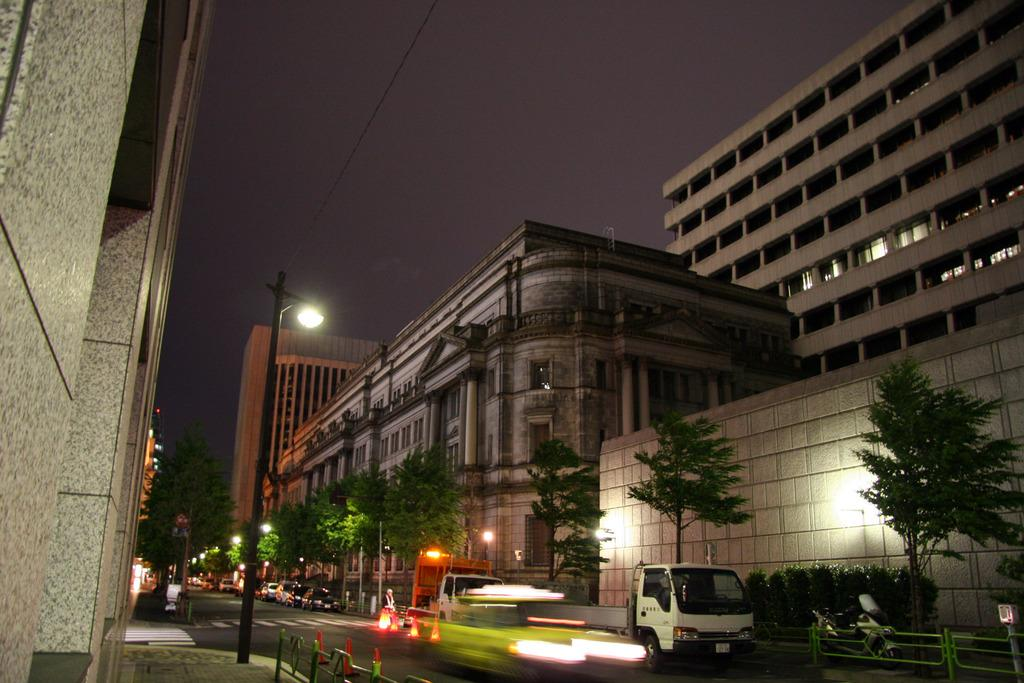What is happening on the road in the image? There are vehicles on the road in the image. What might be used to direct traffic or indicate a hazard in the image? Traffic cones are present on the road in the image. What can be seen in the background of the image? There are trees, poles, buildings, and lights in the background of the image. What type of pump can be seen in the image? There is no pump present in the image. What trick is being performed by the vehicles in the image? The vehicles are not performing any tricks in the image; they are simply driving on the road. 